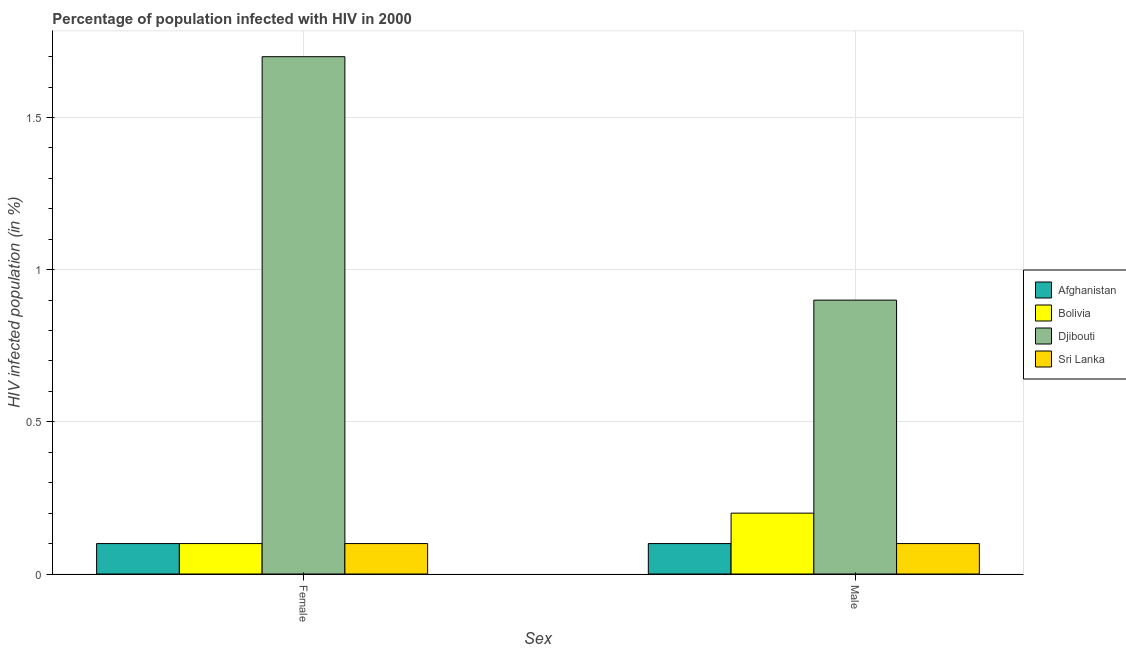How many groups of bars are there?
Offer a terse response. 2. Are the number of bars per tick equal to the number of legend labels?
Ensure brevity in your answer.  Yes. How many bars are there on the 1st tick from the left?
Offer a terse response. 4. How many bars are there on the 1st tick from the right?
Provide a short and direct response. 4. What is the label of the 2nd group of bars from the left?
Offer a very short reply. Male. What is the percentage of females who are infected with hiv in Bolivia?
Your answer should be compact. 0.1. Across all countries, what is the maximum percentage of males who are infected with hiv?
Ensure brevity in your answer.  0.9. Across all countries, what is the minimum percentage of females who are infected with hiv?
Provide a short and direct response. 0.1. In which country was the percentage of females who are infected with hiv maximum?
Your answer should be very brief. Djibouti. In which country was the percentage of females who are infected with hiv minimum?
Provide a succinct answer. Afghanistan. What is the total percentage of males who are infected with hiv in the graph?
Offer a terse response. 1.3. What is the difference between the percentage of females who are infected with hiv in Bolivia and that in Djibouti?
Ensure brevity in your answer.  -1.6. What is the difference between the percentage of females who are infected with hiv in Djibouti and the percentage of males who are infected with hiv in Sri Lanka?
Provide a short and direct response. 1.6. What is the average percentage of males who are infected with hiv per country?
Keep it short and to the point. 0.33. Is the percentage of males who are infected with hiv in Afghanistan less than that in Bolivia?
Provide a short and direct response. Yes. What does the 4th bar from the left in Male represents?
Provide a short and direct response. Sri Lanka. What does the 3rd bar from the right in Female represents?
Offer a terse response. Bolivia. How many countries are there in the graph?
Offer a terse response. 4. What is the difference between two consecutive major ticks on the Y-axis?
Your answer should be very brief. 0.5. Are the values on the major ticks of Y-axis written in scientific E-notation?
Ensure brevity in your answer.  No. Where does the legend appear in the graph?
Give a very brief answer. Center right. How are the legend labels stacked?
Offer a very short reply. Vertical. What is the title of the graph?
Offer a very short reply. Percentage of population infected with HIV in 2000. Does "Egypt, Arab Rep." appear as one of the legend labels in the graph?
Offer a very short reply. No. What is the label or title of the X-axis?
Your answer should be compact. Sex. What is the label or title of the Y-axis?
Provide a short and direct response. HIV infected population (in %). What is the HIV infected population (in %) of Afghanistan in Female?
Provide a short and direct response. 0.1. What is the HIV infected population (in %) in Bolivia in Male?
Make the answer very short. 0.2. What is the HIV infected population (in %) in Sri Lanka in Male?
Make the answer very short. 0.1. Across all Sex, what is the maximum HIV infected population (in %) of Djibouti?
Keep it short and to the point. 1.7. Across all Sex, what is the minimum HIV infected population (in %) in Bolivia?
Provide a succinct answer. 0.1. Across all Sex, what is the minimum HIV infected population (in %) in Sri Lanka?
Provide a succinct answer. 0.1. What is the total HIV infected population (in %) of Bolivia in the graph?
Provide a succinct answer. 0.3. What is the total HIV infected population (in %) of Djibouti in the graph?
Provide a succinct answer. 2.6. What is the difference between the HIV infected population (in %) of Afghanistan in Female and that in Male?
Offer a very short reply. 0. What is the difference between the HIV infected population (in %) of Djibouti in Female and that in Male?
Provide a short and direct response. 0.8. What is the difference between the HIV infected population (in %) in Sri Lanka in Female and that in Male?
Make the answer very short. 0. What is the difference between the HIV infected population (in %) in Afghanistan in Female and the HIV infected population (in %) in Bolivia in Male?
Keep it short and to the point. -0.1. What is the average HIV infected population (in %) in Djibouti per Sex?
Offer a terse response. 1.3. What is the difference between the HIV infected population (in %) in Afghanistan and HIV infected population (in %) in Sri Lanka in Female?
Ensure brevity in your answer.  0. What is the difference between the HIV infected population (in %) of Afghanistan and HIV infected population (in %) of Djibouti in Male?
Make the answer very short. -0.8. What is the difference between the HIV infected population (in %) in Afghanistan and HIV infected population (in %) in Sri Lanka in Male?
Offer a terse response. 0. What is the difference between the HIV infected population (in %) in Bolivia and HIV infected population (in %) in Sri Lanka in Male?
Your answer should be compact. 0.1. What is the difference between the HIV infected population (in %) of Djibouti and HIV infected population (in %) of Sri Lanka in Male?
Your response must be concise. 0.8. What is the ratio of the HIV infected population (in %) of Afghanistan in Female to that in Male?
Offer a very short reply. 1. What is the ratio of the HIV infected population (in %) in Bolivia in Female to that in Male?
Provide a succinct answer. 0.5. What is the ratio of the HIV infected population (in %) in Djibouti in Female to that in Male?
Your answer should be very brief. 1.89. What is the ratio of the HIV infected population (in %) in Sri Lanka in Female to that in Male?
Your answer should be compact. 1. What is the difference between the highest and the lowest HIV infected population (in %) in Afghanistan?
Give a very brief answer. 0. What is the difference between the highest and the lowest HIV infected population (in %) in Bolivia?
Your answer should be very brief. 0.1. What is the difference between the highest and the lowest HIV infected population (in %) in Djibouti?
Keep it short and to the point. 0.8. 